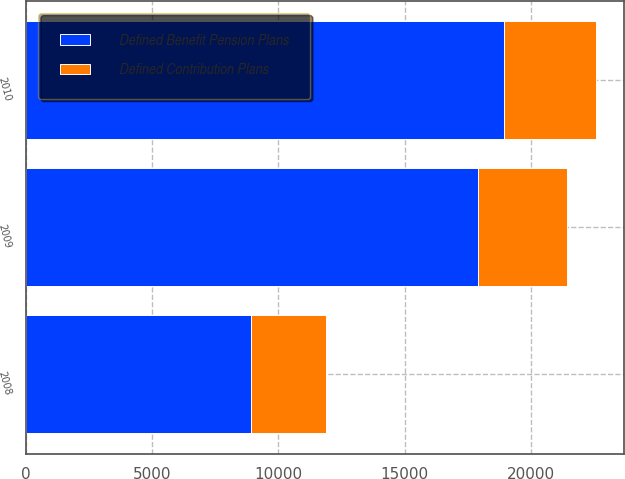Convert chart to OTSL. <chart><loc_0><loc_0><loc_500><loc_500><stacked_bar_chart><ecel><fcel>2010<fcel>2009<fcel>2008<nl><fcel>Defined Contribution Plans<fcel>3617<fcel>3511<fcel>2988<nl><fcel>Defined Benefit Pension Plans<fcel>18948<fcel>17912<fcel>8918<nl></chart> 